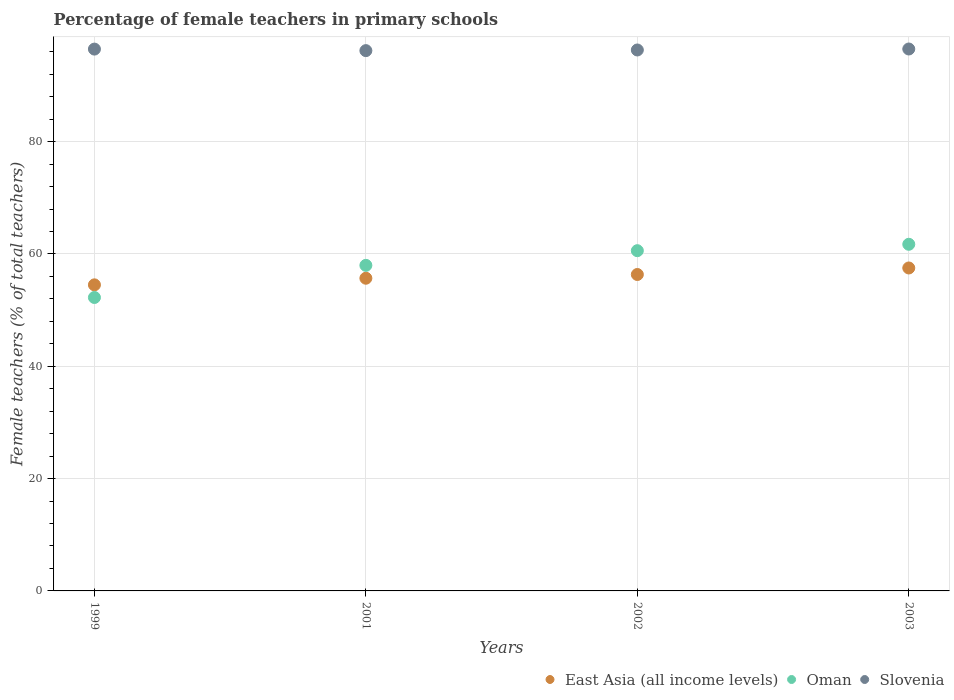How many different coloured dotlines are there?
Your answer should be very brief. 3. What is the percentage of female teachers in Oman in 2003?
Your answer should be very brief. 61.72. Across all years, what is the maximum percentage of female teachers in Oman?
Ensure brevity in your answer.  61.72. Across all years, what is the minimum percentage of female teachers in Oman?
Your answer should be very brief. 52.25. In which year was the percentage of female teachers in East Asia (all income levels) maximum?
Ensure brevity in your answer.  2003. What is the total percentage of female teachers in East Asia (all income levels) in the graph?
Keep it short and to the point. 224.03. What is the difference between the percentage of female teachers in Oman in 2002 and that in 2003?
Provide a short and direct response. -1.14. What is the difference between the percentage of female teachers in Oman in 1999 and the percentage of female teachers in East Asia (all income levels) in 2001?
Provide a short and direct response. -3.43. What is the average percentage of female teachers in East Asia (all income levels) per year?
Ensure brevity in your answer.  56.01. In the year 1999, what is the difference between the percentage of female teachers in East Asia (all income levels) and percentage of female teachers in Slovenia?
Offer a terse response. -41.98. What is the ratio of the percentage of female teachers in Slovenia in 1999 to that in 2003?
Ensure brevity in your answer.  1. Is the percentage of female teachers in Oman in 1999 less than that in 2002?
Offer a terse response. Yes. What is the difference between the highest and the second highest percentage of female teachers in Slovenia?
Your answer should be compact. 0.02. What is the difference between the highest and the lowest percentage of female teachers in Oman?
Provide a short and direct response. 9.47. In how many years, is the percentage of female teachers in Oman greater than the average percentage of female teachers in Oman taken over all years?
Make the answer very short. 2. Is the sum of the percentage of female teachers in East Asia (all income levels) in 1999 and 2001 greater than the maximum percentage of female teachers in Oman across all years?
Offer a very short reply. Yes. Does the percentage of female teachers in Slovenia monotonically increase over the years?
Offer a very short reply. No. Is the percentage of female teachers in Slovenia strictly less than the percentage of female teachers in Oman over the years?
Offer a terse response. No. How many years are there in the graph?
Offer a terse response. 4. What is the difference between two consecutive major ticks on the Y-axis?
Provide a short and direct response. 20. Does the graph contain any zero values?
Provide a succinct answer. No. Where does the legend appear in the graph?
Offer a very short reply. Bottom right. How are the legend labels stacked?
Offer a terse response. Horizontal. What is the title of the graph?
Your answer should be compact. Percentage of female teachers in primary schools. Does "Paraguay" appear as one of the legend labels in the graph?
Provide a short and direct response. No. What is the label or title of the Y-axis?
Keep it short and to the point. Female teachers (% of total teachers). What is the Female teachers (% of total teachers) of East Asia (all income levels) in 1999?
Your response must be concise. 54.5. What is the Female teachers (% of total teachers) of Oman in 1999?
Provide a short and direct response. 52.25. What is the Female teachers (% of total teachers) in Slovenia in 1999?
Your answer should be compact. 96.48. What is the Female teachers (% of total teachers) of East Asia (all income levels) in 2001?
Make the answer very short. 55.68. What is the Female teachers (% of total teachers) in Oman in 2001?
Provide a succinct answer. 57.97. What is the Female teachers (% of total teachers) in Slovenia in 2001?
Give a very brief answer. 96.21. What is the Female teachers (% of total teachers) of East Asia (all income levels) in 2002?
Offer a very short reply. 56.34. What is the Female teachers (% of total teachers) in Oman in 2002?
Offer a terse response. 60.59. What is the Female teachers (% of total teachers) of Slovenia in 2002?
Keep it short and to the point. 96.32. What is the Female teachers (% of total teachers) of East Asia (all income levels) in 2003?
Offer a very short reply. 57.51. What is the Female teachers (% of total teachers) in Oman in 2003?
Make the answer very short. 61.72. What is the Female teachers (% of total teachers) in Slovenia in 2003?
Give a very brief answer. 96.5. Across all years, what is the maximum Female teachers (% of total teachers) in East Asia (all income levels)?
Offer a terse response. 57.51. Across all years, what is the maximum Female teachers (% of total teachers) of Oman?
Ensure brevity in your answer.  61.72. Across all years, what is the maximum Female teachers (% of total teachers) in Slovenia?
Your answer should be compact. 96.5. Across all years, what is the minimum Female teachers (% of total teachers) of East Asia (all income levels)?
Give a very brief answer. 54.5. Across all years, what is the minimum Female teachers (% of total teachers) of Oman?
Give a very brief answer. 52.25. Across all years, what is the minimum Female teachers (% of total teachers) of Slovenia?
Provide a short and direct response. 96.21. What is the total Female teachers (% of total teachers) in East Asia (all income levels) in the graph?
Keep it short and to the point. 224.03. What is the total Female teachers (% of total teachers) in Oman in the graph?
Keep it short and to the point. 232.53. What is the total Female teachers (% of total teachers) of Slovenia in the graph?
Provide a short and direct response. 385.51. What is the difference between the Female teachers (% of total teachers) in East Asia (all income levels) in 1999 and that in 2001?
Your answer should be compact. -1.18. What is the difference between the Female teachers (% of total teachers) of Oman in 1999 and that in 2001?
Your answer should be compact. -5.72. What is the difference between the Female teachers (% of total teachers) in Slovenia in 1999 and that in 2001?
Your answer should be very brief. 0.27. What is the difference between the Female teachers (% of total teachers) of East Asia (all income levels) in 1999 and that in 2002?
Make the answer very short. -1.84. What is the difference between the Female teachers (% of total teachers) in Oman in 1999 and that in 2002?
Your answer should be very brief. -8.34. What is the difference between the Female teachers (% of total teachers) in Slovenia in 1999 and that in 2002?
Your response must be concise. 0.16. What is the difference between the Female teachers (% of total teachers) of East Asia (all income levels) in 1999 and that in 2003?
Offer a terse response. -3.01. What is the difference between the Female teachers (% of total teachers) in Oman in 1999 and that in 2003?
Your answer should be compact. -9.47. What is the difference between the Female teachers (% of total teachers) of Slovenia in 1999 and that in 2003?
Your answer should be very brief. -0.02. What is the difference between the Female teachers (% of total teachers) in East Asia (all income levels) in 2001 and that in 2002?
Offer a terse response. -0.67. What is the difference between the Female teachers (% of total teachers) in Oman in 2001 and that in 2002?
Your response must be concise. -2.61. What is the difference between the Female teachers (% of total teachers) of Slovenia in 2001 and that in 2002?
Your response must be concise. -0.12. What is the difference between the Female teachers (% of total teachers) of East Asia (all income levels) in 2001 and that in 2003?
Provide a succinct answer. -1.83. What is the difference between the Female teachers (% of total teachers) of Oman in 2001 and that in 2003?
Your answer should be very brief. -3.75. What is the difference between the Female teachers (% of total teachers) of Slovenia in 2001 and that in 2003?
Your answer should be very brief. -0.29. What is the difference between the Female teachers (% of total teachers) of East Asia (all income levels) in 2002 and that in 2003?
Your answer should be very brief. -1.16. What is the difference between the Female teachers (% of total teachers) in Oman in 2002 and that in 2003?
Your response must be concise. -1.14. What is the difference between the Female teachers (% of total teachers) in Slovenia in 2002 and that in 2003?
Offer a very short reply. -0.17. What is the difference between the Female teachers (% of total teachers) in East Asia (all income levels) in 1999 and the Female teachers (% of total teachers) in Oman in 2001?
Keep it short and to the point. -3.47. What is the difference between the Female teachers (% of total teachers) in East Asia (all income levels) in 1999 and the Female teachers (% of total teachers) in Slovenia in 2001?
Keep it short and to the point. -41.71. What is the difference between the Female teachers (% of total teachers) of Oman in 1999 and the Female teachers (% of total teachers) of Slovenia in 2001?
Offer a terse response. -43.96. What is the difference between the Female teachers (% of total teachers) of East Asia (all income levels) in 1999 and the Female teachers (% of total teachers) of Oman in 2002?
Give a very brief answer. -6.08. What is the difference between the Female teachers (% of total teachers) in East Asia (all income levels) in 1999 and the Female teachers (% of total teachers) in Slovenia in 2002?
Give a very brief answer. -41.82. What is the difference between the Female teachers (% of total teachers) in Oman in 1999 and the Female teachers (% of total teachers) in Slovenia in 2002?
Your response must be concise. -44.07. What is the difference between the Female teachers (% of total teachers) in East Asia (all income levels) in 1999 and the Female teachers (% of total teachers) in Oman in 2003?
Make the answer very short. -7.22. What is the difference between the Female teachers (% of total teachers) in East Asia (all income levels) in 1999 and the Female teachers (% of total teachers) in Slovenia in 2003?
Make the answer very short. -42. What is the difference between the Female teachers (% of total teachers) in Oman in 1999 and the Female teachers (% of total teachers) in Slovenia in 2003?
Provide a short and direct response. -44.25. What is the difference between the Female teachers (% of total teachers) of East Asia (all income levels) in 2001 and the Female teachers (% of total teachers) of Oman in 2002?
Provide a succinct answer. -4.91. What is the difference between the Female teachers (% of total teachers) of East Asia (all income levels) in 2001 and the Female teachers (% of total teachers) of Slovenia in 2002?
Your answer should be compact. -40.64. What is the difference between the Female teachers (% of total teachers) in Oman in 2001 and the Female teachers (% of total teachers) in Slovenia in 2002?
Offer a very short reply. -38.35. What is the difference between the Female teachers (% of total teachers) in East Asia (all income levels) in 2001 and the Female teachers (% of total teachers) in Oman in 2003?
Make the answer very short. -6.04. What is the difference between the Female teachers (% of total teachers) in East Asia (all income levels) in 2001 and the Female teachers (% of total teachers) in Slovenia in 2003?
Make the answer very short. -40.82. What is the difference between the Female teachers (% of total teachers) of Oman in 2001 and the Female teachers (% of total teachers) of Slovenia in 2003?
Ensure brevity in your answer.  -38.53. What is the difference between the Female teachers (% of total teachers) of East Asia (all income levels) in 2002 and the Female teachers (% of total teachers) of Oman in 2003?
Your answer should be compact. -5.38. What is the difference between the Female teachers (% of total teachers) of East Asia (all income levels) in 2002 and the Female teachers (% of total teachers) of Slovenia in 2003?
Your answer should be very brief. -40.15. What is the difference between the Female teachers (% of total teachers) in Oman in 2002 and the Female teachers (% of total teachers) in Slovenia in 2003?
Keep it short and to the point. -35.91. What is the average Female teachers (% of total teachers) in East Asia (all income levels) per year?
Provide a short and direct response. 56.01. What is the average Female teachers (% of total teachers) in Oman per year?
Ensure brevity in your answer.  58.13. What is the average Female teachers (% of total teachers) of Slovenia per year?
Offer a very short reply. 96.38. In the year 1999, what is the difference between the Female teachers (% of total teachers) of East Asia (all income levels) and Female teachers (% of total teachers) of Oman?
Provide a succinct answer. 2.25. In the year 1999, what is the difference between the Female teachers (% of total teachers) of East Asia (all income levels) and Female teachers (% of total teachers) of Slovenia?
Your response must be concise. -41.98. In the year 1999, what is the difference between the Female teachers (% of total teachers) of Oman and Female teachers (% of total teachers) of Slovenia?
Provide a short and direct response. -44.23. In the year 2001, what is the difference between the Female teachers (% of total teachers) of East Asia (all income levels) and Female teachers (% of total teachers) of Oman?
Your response must be concise. -2.29. In the year 2001, what is the difference between the Female teachers (% of total teachers) in East Asia (all income levels) and Female teachers (% of total teachers) in Slovenia?
Give a very brief answer. -40.53. In the year 2001, what is the difference between the Female teachers (% of total teachers) in Oman and Female teachers (% of total teachers) in Slovenia?
Your answer should be very brief. -38.24. In the year 2002, what is the difference between the Female teachers (% of total teachers) of East Asia (all income levels) and Female teachers (% of total teachers) of Oman?
Keep it short and to the point. -4.24. In the year 2002, what is the difference between the Female teachers (% of total teachers) of East Asia (all income levels) and Female teachers (% of total teachers) of Slovenia?
Your answer should be compact. -39.98. In the year 2002, what is the difference between the Female teachers (% of total teachers) in Oman and Female teachers (% of total teachers) in Slovenia?
Offer a very short reply. -35.74. In the year 2003, what is the difference between the Female teachers (% of total teachers) of East Asia (all income levels) and Female teachers (% of total teachers) of Oman?
Keep it short and to the point. -4.22. In the year 2003, what is the difference between the Female teachers (% of total teachers) in East Asia (all income levels) and Female teachers (% of total teachers) in Slovenia?
Your answer should be compact. -38.99. In the year 2003, what is the difference between the Female teachers (% of total teachers) of Oman and Female teachers (% of total teachers) of Slovenia?
Provide a succinct answer. -34.77. What is the ratio of the Female teachers (% of total teachers) in East Asia (all income levels) in 1999 to that in 2001?
Make the answer very short. 0.98. What is the ratio of the Female teachers (% of total teachers) of Oman in 1999 to that in 2001?
Give a very brief answer. 0.9. What is the ratio of the Female teachers (% of total teachers) in Slovenia in 1999 to that in 2001?
Provide a succinct answer. 1. What is the ratio of the Female teachers (% of total teachers) of East Asia (all income levels) in 1999 to that in 2002?
Provide a succinct answer. 0.97. What is the ratio of the Female teachers (% of total teachers) of Oman in 1999 to that in 2002?
Keep it short and to the point. 0.86. What is the ratio of the Female teachers (% of total teachers) in East Asia (all income levels) in 1999 to that in 2003?
Offer a very short reply. 0.95. What is the ratio of the Female teachers (% of total teachers) of Oman in 1999 to that in 2003?
Make the answer very short. 0.85. What is the ratio of the Female teachers (% of total teachers) in Oman in 2001 to that in 2002?
Give a very brief answer. 0.96. What is the ratio of the Female teachers (% of total teachers) in East Asia (all income levels) in 2001 to that in 2003?
Your answer should be very brief. 0.97. What is the ratio of the Female teachers (% of total teachers) in Oman in 2001 to that in 2003?
Your answer should be compact. 0.94. What is the ratio of the Female teachers (% of total teachers) of Slovenia in 2001 to that in 2003?
Keep it short and to the point. 1. What is the ratio of the Female teachers (% of total teachers) in East Asia (all income levels) in 2002 to that in 2003?
Offer a very short reply. 0.98. What is the ratio of the Female teachers (% of total teachers) in Oman in 2002 to that in 2003?
Make the answer very short. 0.98. What is the difference between the highest and the second highest Female teachers (% of total teachers) of East Asia (all income levels)?
Offer a very short reply. 1.16. What is the difference between the highest and the second highest Female teachers (% of total teachers) in Oman?
Offer a very short reply. 1.14. What is the difference between the highest and the second highest Female teachers (% of total teachers) of Slovenia?
Give a very brief answer. 0.02. What is the difference between the highest and the lowest Female teachers (% of total teachers) in East Asia (all income levels)?
Provide a succinct answer. 3.01. What is the difference between the highest and the lowest Female teachers (% of total teachers) in Oman?
Ensure brevity in your answer.  9.47. What is the difference between the highest and the lowest Female teachers (% of total teachers) in Slovenia?
Offer a very short reply. 0.29. 